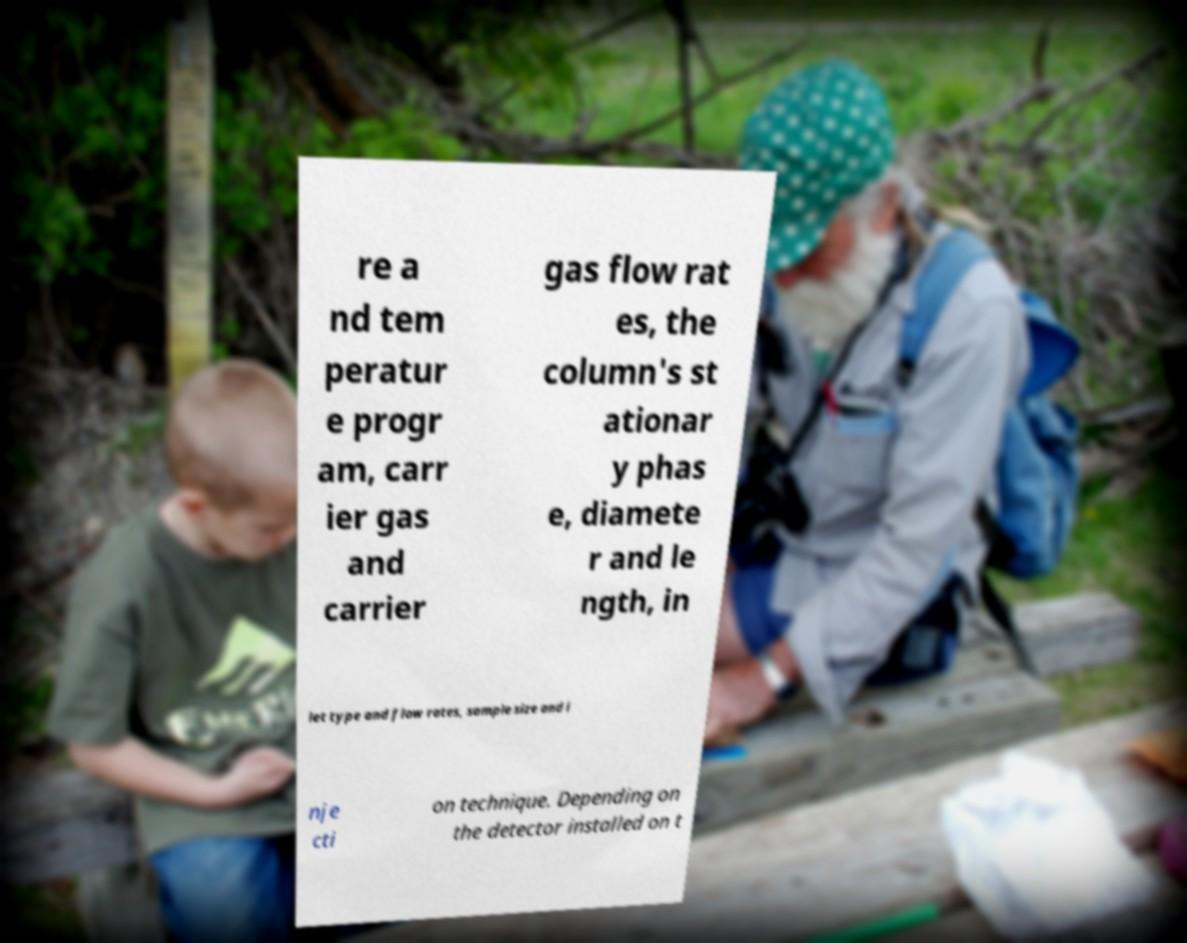I need the written content from this picture converted into text. Can you do that? re a nd tem peratur e progr am, carr ier gas and carrier gas flow rat es, the column's st ationar y phas e, diamete r and le ngth, in let type and flow rates, sample size and i nje cti on technique. Depending on the detector installed on t 